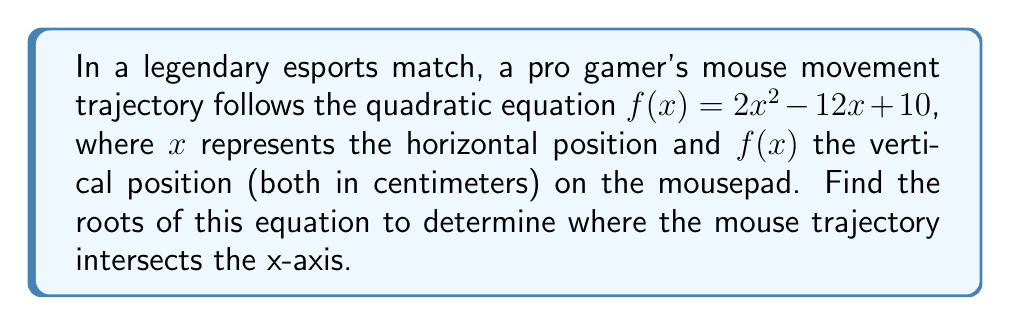Teach me how to tackle this problem. To find the roots of the quadratic equation $f(x) = 2x^2 - 12x + 10$, we need to solve $f(x) = 0$:

1) Set the equation equal to zero:
   $2x^2 - 12x + 10 = 0$

2) Identify the coefficients:
   $a = 2$, $b = -12$, $c = 10$

3) Use the quadratic formula: $x = \frac{-b \pm \sqrt{b^2 - 4ac}}{2a}$

4) Substitute the values:
   $x = \frac{-(-12) \pm \sqrt{(-12)^2 - 4(2)(10)}}{2(2)}$

5) Simplify:
   $x = \frac{12 \pm \sqrt{144 - 80}}{4} = \frac{12 \pm \sqrt{64}}{4} = \frac{12 \pm 8}{4}$

6) Calculate the two roots:
   $x_1 = \frac{12 + 8}{4} = \frac{20}{4} = 5$
   $x_2 = \frac{12 - 8}{4} = \frac{4}{4} = 1$

Therefore, the mouse trajectory intersects the x-axis at $x = 1$ and $x = 5$ centimeters.
Answer: $x = 1$ and $x = 5$ 